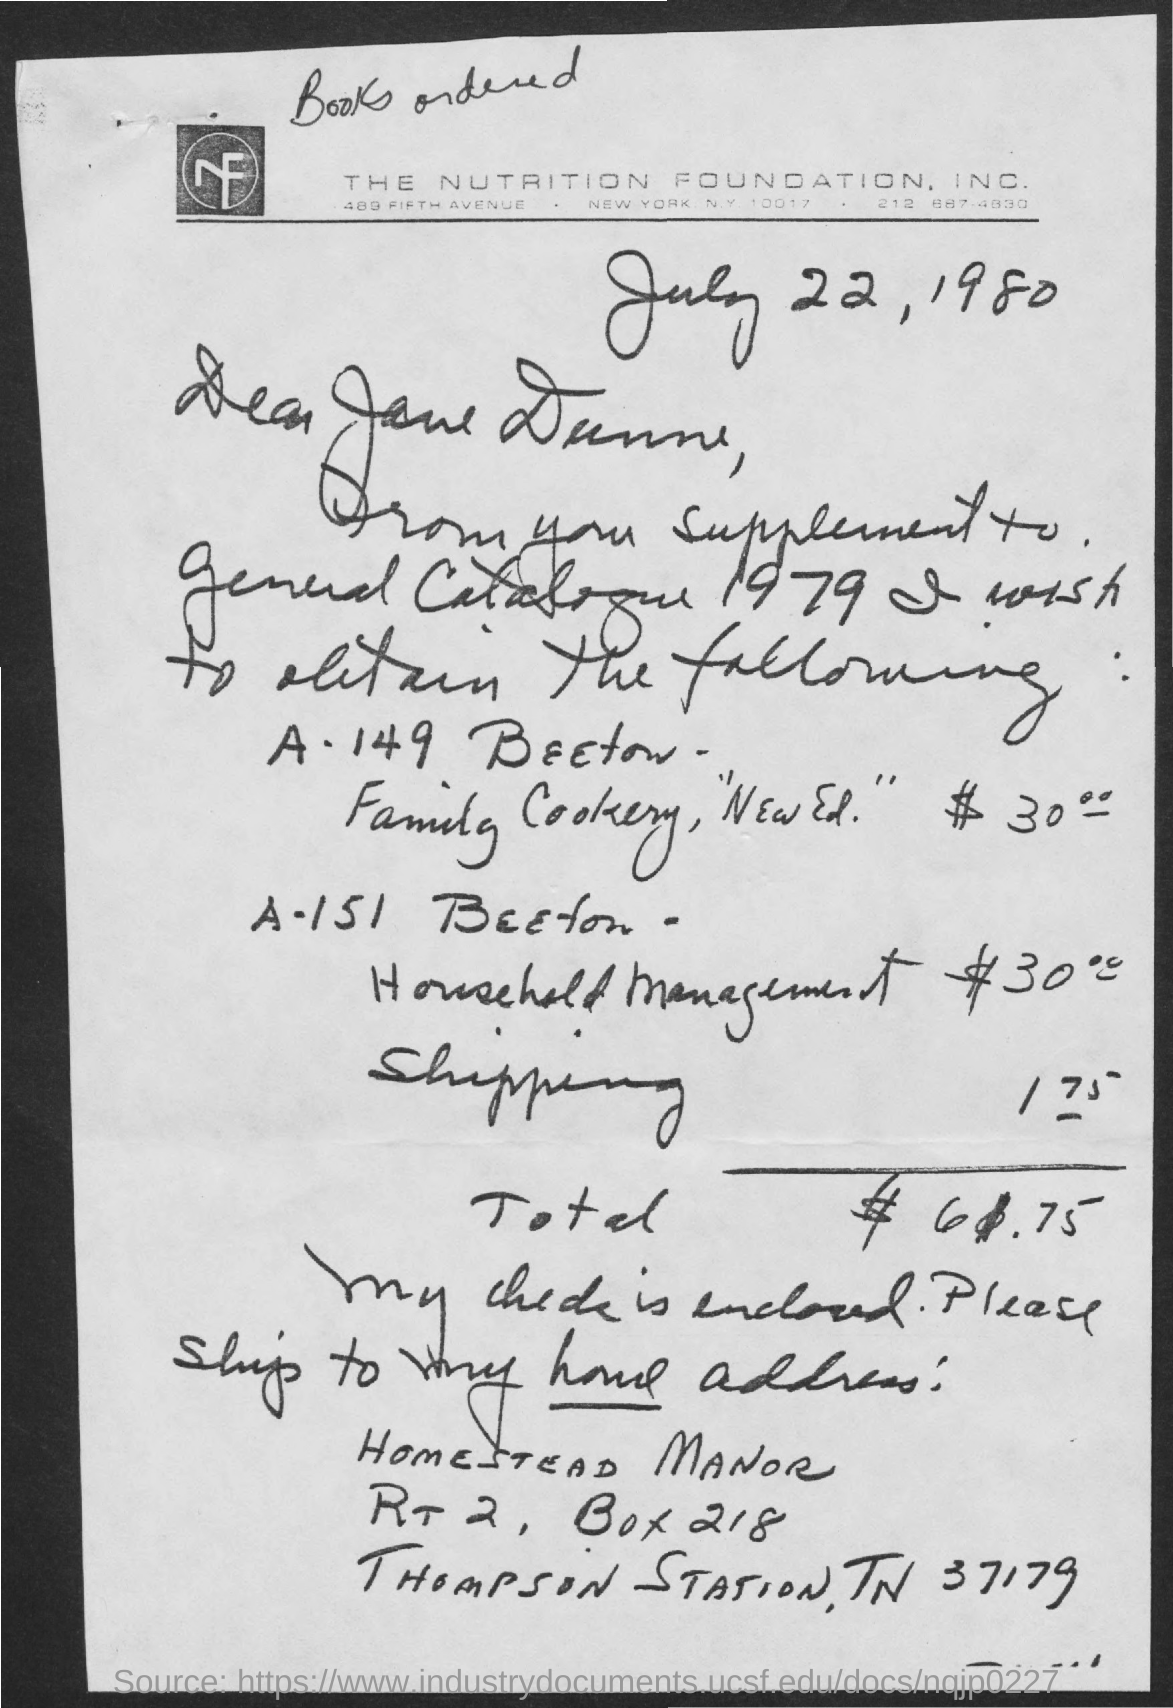Which company is mentioned in the letter head?
Provide a succinct answer. THE NUTRITION FOUNDATION, INC. What is the letter dated?
Offer a terse response. July 22, 1980. What is the total amount mentioned in the letter?
Your answer should be compact. $ 61.75. 